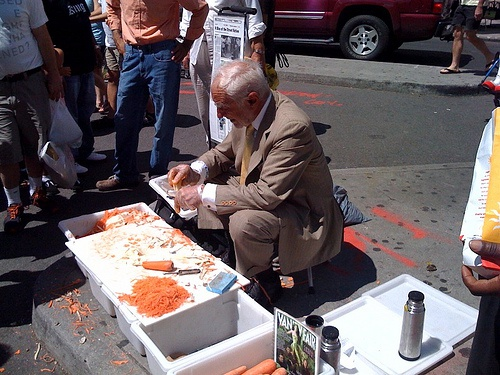Describe the objects in this image and their specific colors. I can see people in darkblue, black, maroon, darkgray, and gray tones, people in darkblue, black, and gray tones, people in darkblue, black, maroon, navy, and brown tones, people in darkblue, black, white, gold, and gray tones, and car in darkblue, black, gray, maroon, and darkgray tones in this image. 